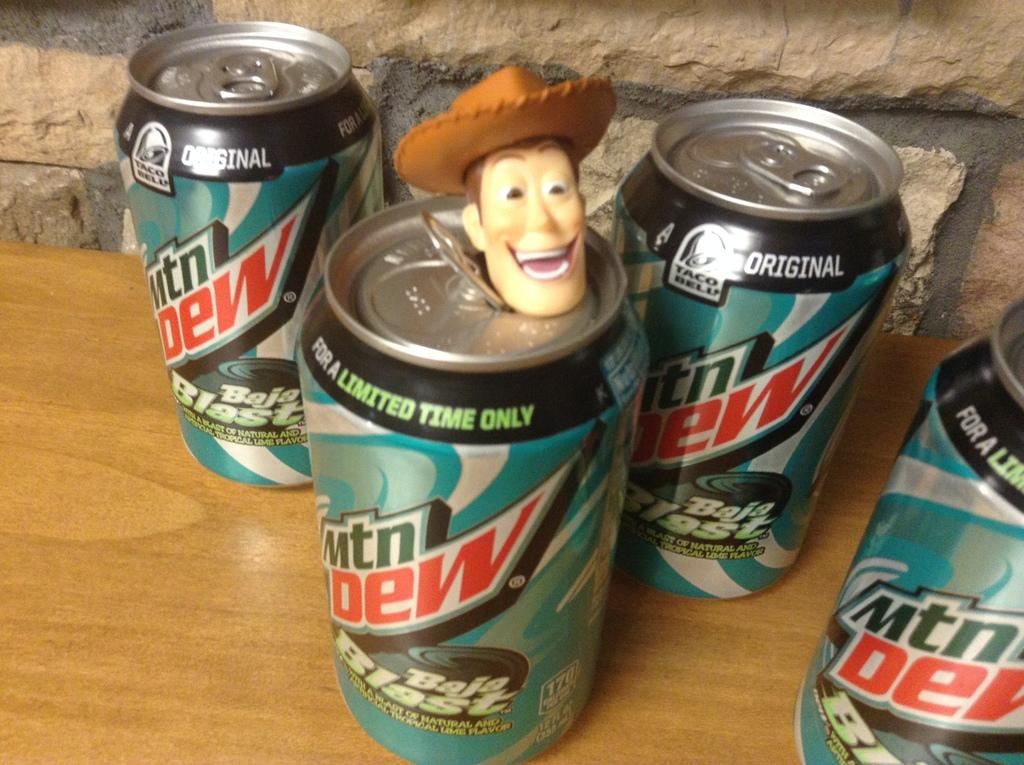<image>
Describe the image concisely. A can of Mountain Dew has a figurine of "Woody" on top of it. 